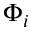Convert formula to latex. <formula><loc_0><loc_0><loc_500><loc_500>\Phi _ { i }</formula> 